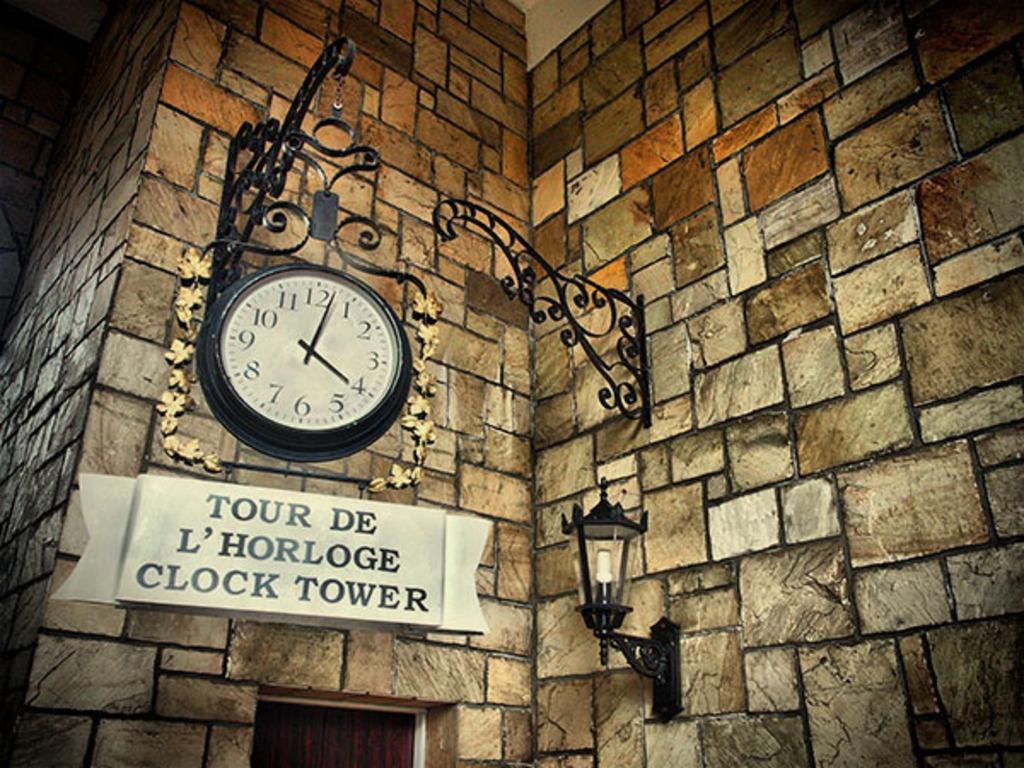What is the current time being shown?
Offer a very short reply. 4:02. What is the first word on the sign?
Ensure brevity in your answer.  Tour. 